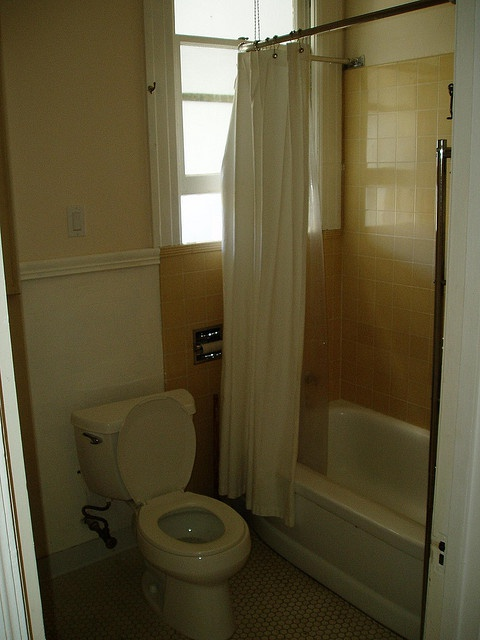Describe the objects in this image and their specific colors. I can see a toilet in black, darkgreen, and gray tones in this image. 